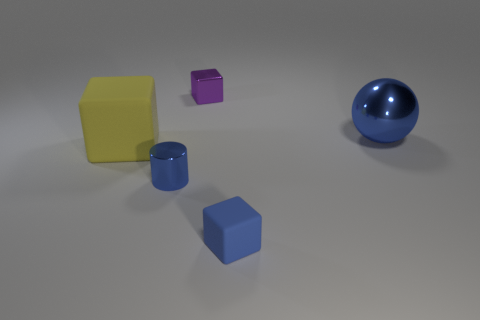Subtract all purple blocks. How many blocks are left? 2 Add 2 big matte things. How many objects exist? 7 Subtract all purple blocks. How many blocks are left? 2 Add 2 small purple shiny objects. How many small purple shiny objects are left? 3 Add 5 tiny blue rubber cubes. How many tiny blue rubber cubes exist? 6 Subtract 0 gray cylinders. How many objects are left? 5 Subtract all blocks. How many objects are left? 2 Subtract all red balls. Subtract all red blocks. How many balls are left? 1 Subtract all cyan balls. How many purple blocks are left? 1 Subtract all cyan rubber balls. Subtract all big blocks. How many objects are left? 4 